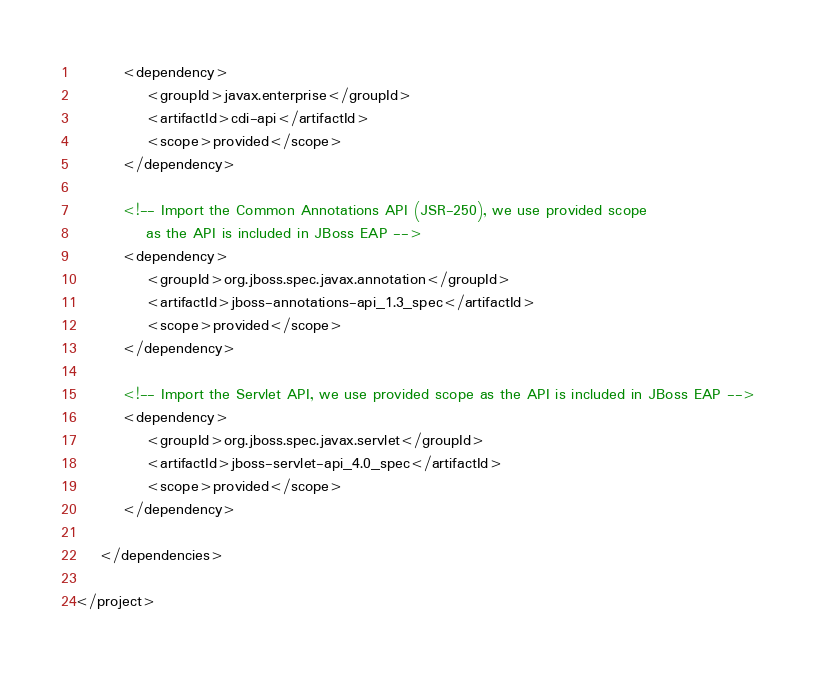<code> <loc_0><loc_0><loc_500><loc_500><_XML_>        <dependency>
            <groupId>javax.enterprise</groupId>
            <artifactId>cdi-api</artifactId>
            <scope>provided</scope>
        </dependency>

        <!-- Import the Common Annotations API (JSR-250), we use provided scope
            as the API is included in JBoss EAP -->
        <dependency>
            <groupId>org.jboss.spec.javax.annotation</groupId>
            <artifactId>jboss-annotations-api_1.3_spec</artifactId>
            <scope>provided</scope>
        </dependency>

        <!-- Import the Servlet API, we use provided scope as the API is included in JBoss EAP -->
        <dependency>
            <groupId>org.jboss.spec.javax.servlet</groupId>
            <artifactId>jboss-servlet-api_4.0_spec</artifactId>
            <scope>provided</scope>
        </dependency>

    </dependencies>
        
</project>
</code> 